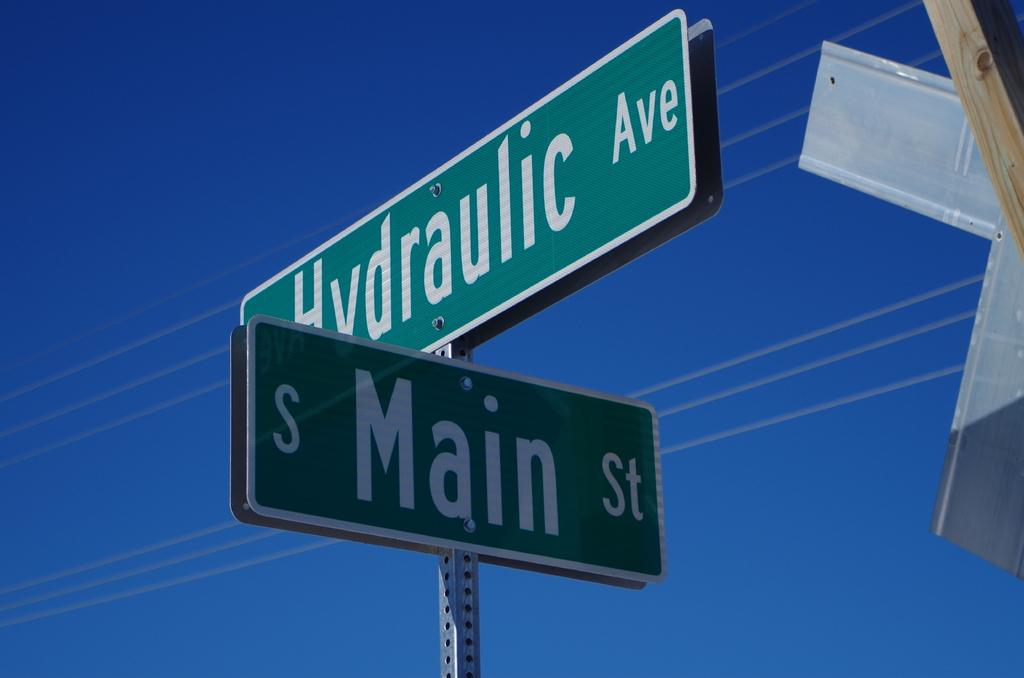<image>
Offer a succinct explanation of the picture presented. close up of two street signs for Hydraulic Ave and Main St 